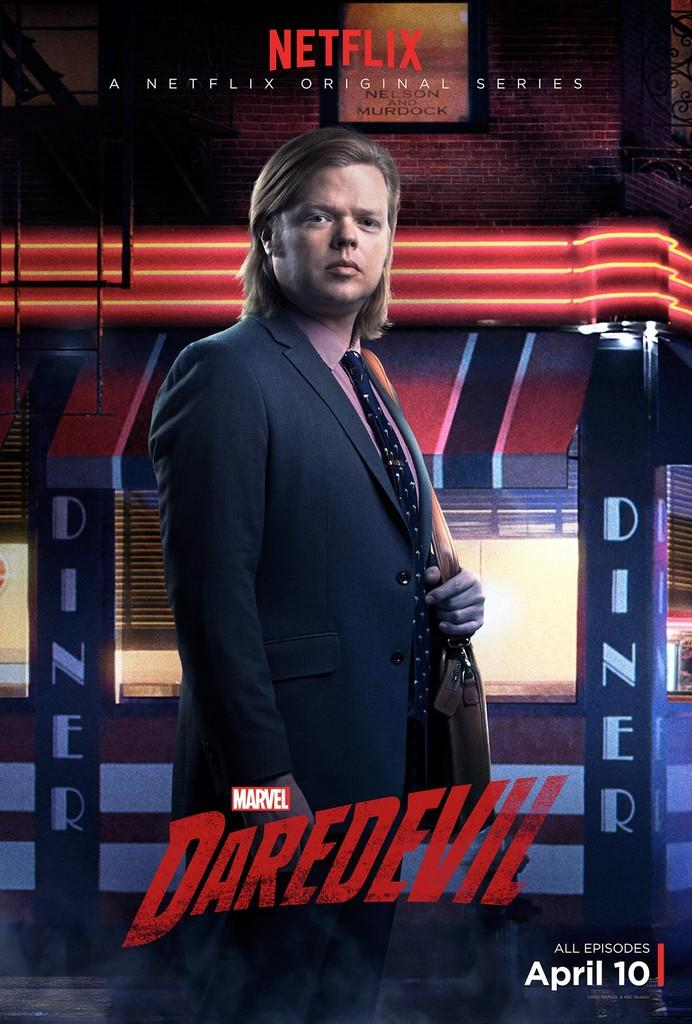What is the main subject of the advertisement in the image? There is an advertisement with text in the image, but the specific content of the advertisement is not mentioned. Can you describe the person in the image? There is a person in the image, and they are wearing clothes. What can be seen in the background of the image? There is a building in the background of the image. How many planes are flying over the person in the image? There is no mention of planes in the image, so it is not possible to determine how many are flying over the person. 